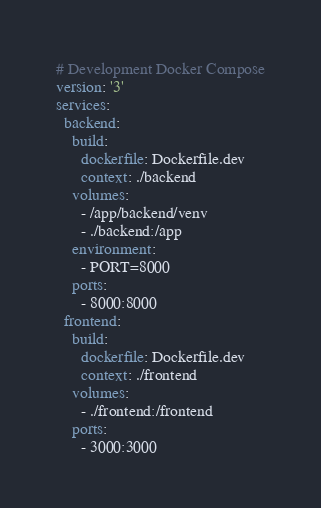Convert code to text. <code><loc_0><loc_0><loc_500><loc_500><_YAML_># Development Docker Compose
version: '3'
services:
  backend:
    build:
      dockerfile: Dockerfile.dev 
      context: ./backend 
    volumes:
      - /app/backend/venv
      - ./backend:/app
    environment:
      - PORT=8000
    ports:
      - 8000:8000
  frontend:
    build:
      dockerfile: Dockerfile.dev
      context: ./frontend
    volumes:
      - ./frontend:/frontend
    ports:
      - 3000:3000
</code> 